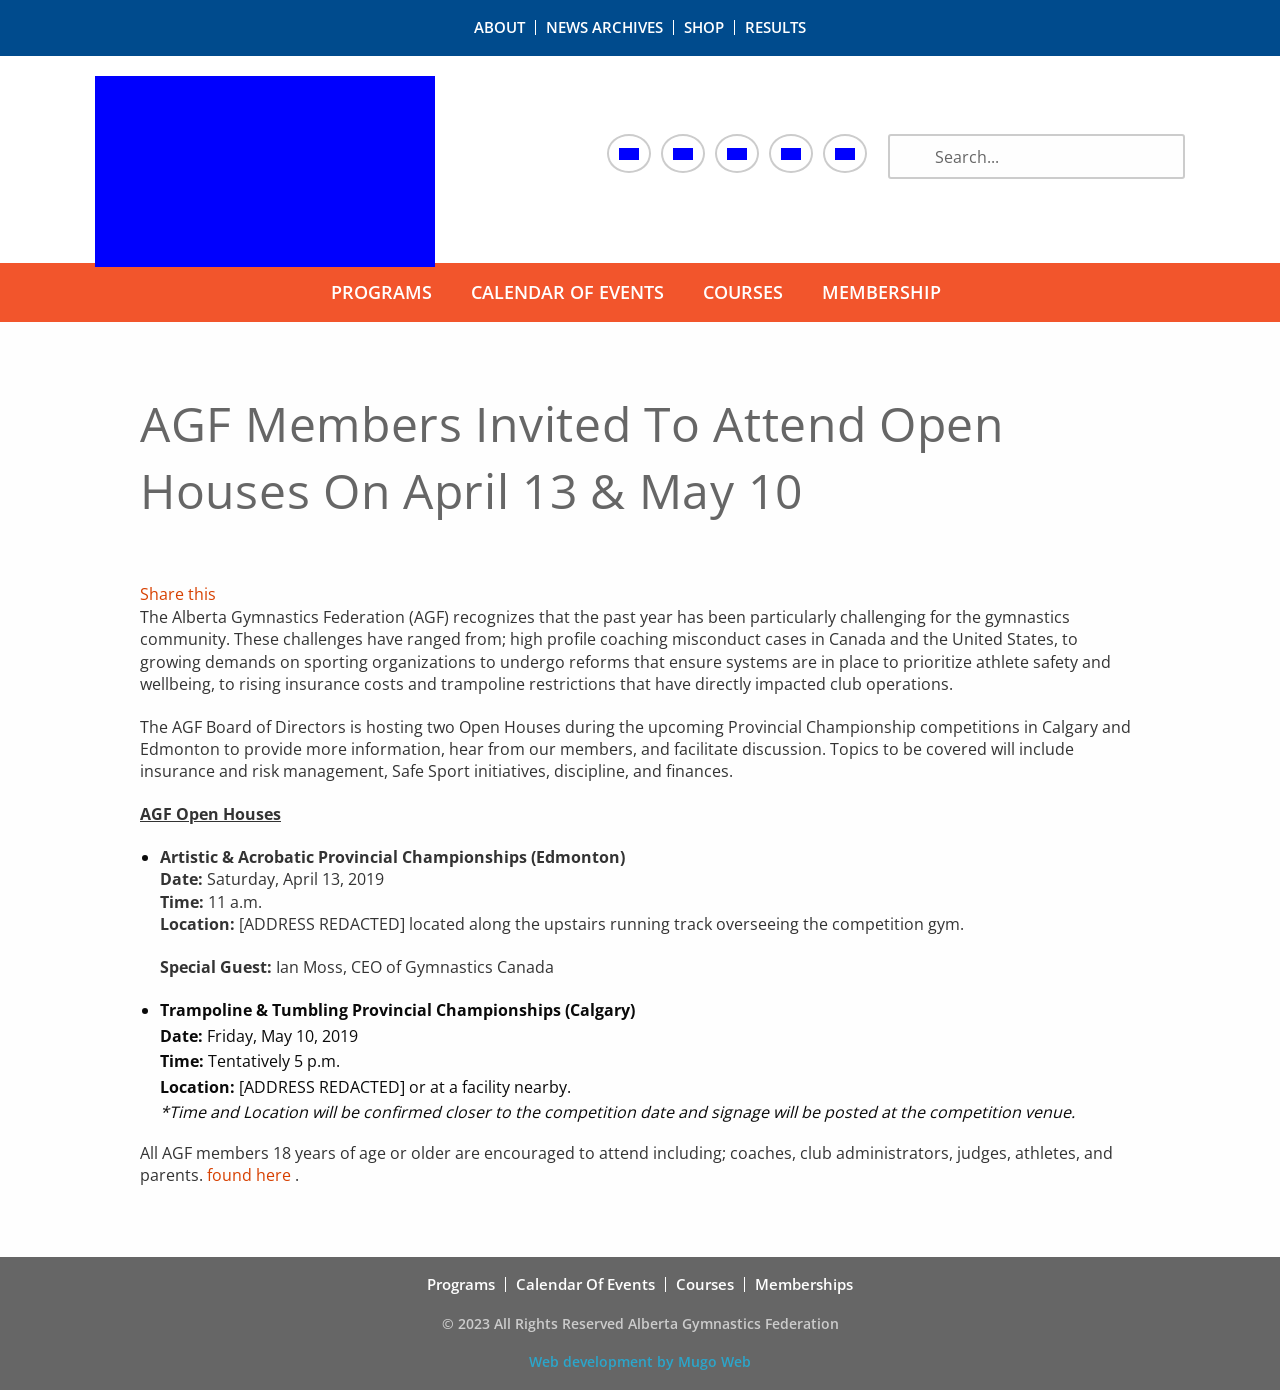Can you tell me more about the topics that will be discussed during these open houses? Certainly! The open houses will cover several critical topics, including insurance and risk management, which are vital for maintaining the smooth operation of sports organizations. They will also delve into Safe Sport initiatives, aimed at ensuring athlete safety and well-being. Furthermore, discussions will include disciplinary measures and financial management within the AGF, all crucial for fostering a safe and positive environment for gymnasts.  Who is invited to attend these sessions? All AGF members who are 18 years of age or older are welcome at the open houses. This includes a wide range of participants such as coaches, club administrators, judges, athletes, and parents. The sessions aim to be inclusive and gather input and perspectives from all corners of the gymnastics community. 